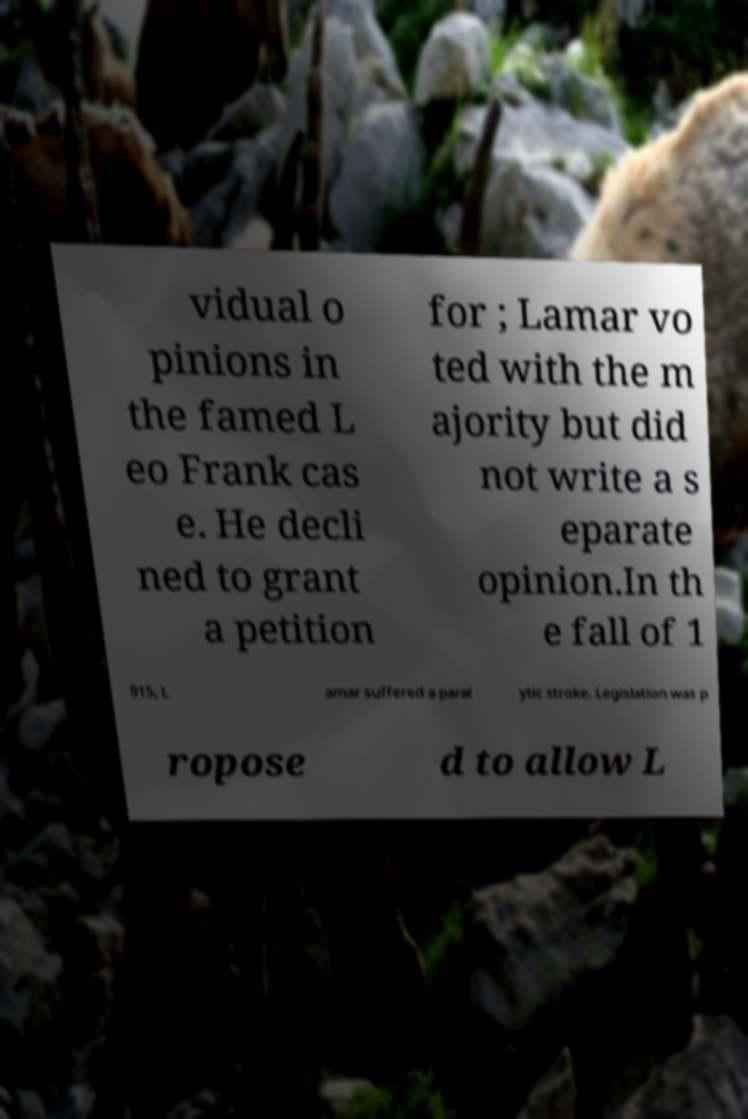For documentation purposes, I need the text within this image transcribed. Could you provide that? vidual o pinions in the famed L eo Frank cas e. He decli ned to grant a petition for ; Lamar vo ted with the m ajority but did not write a s eparate opinion.In th e fall of 1 915, L amar suffered a paral ytic stroke. Legislation was p ropose d to allow L 